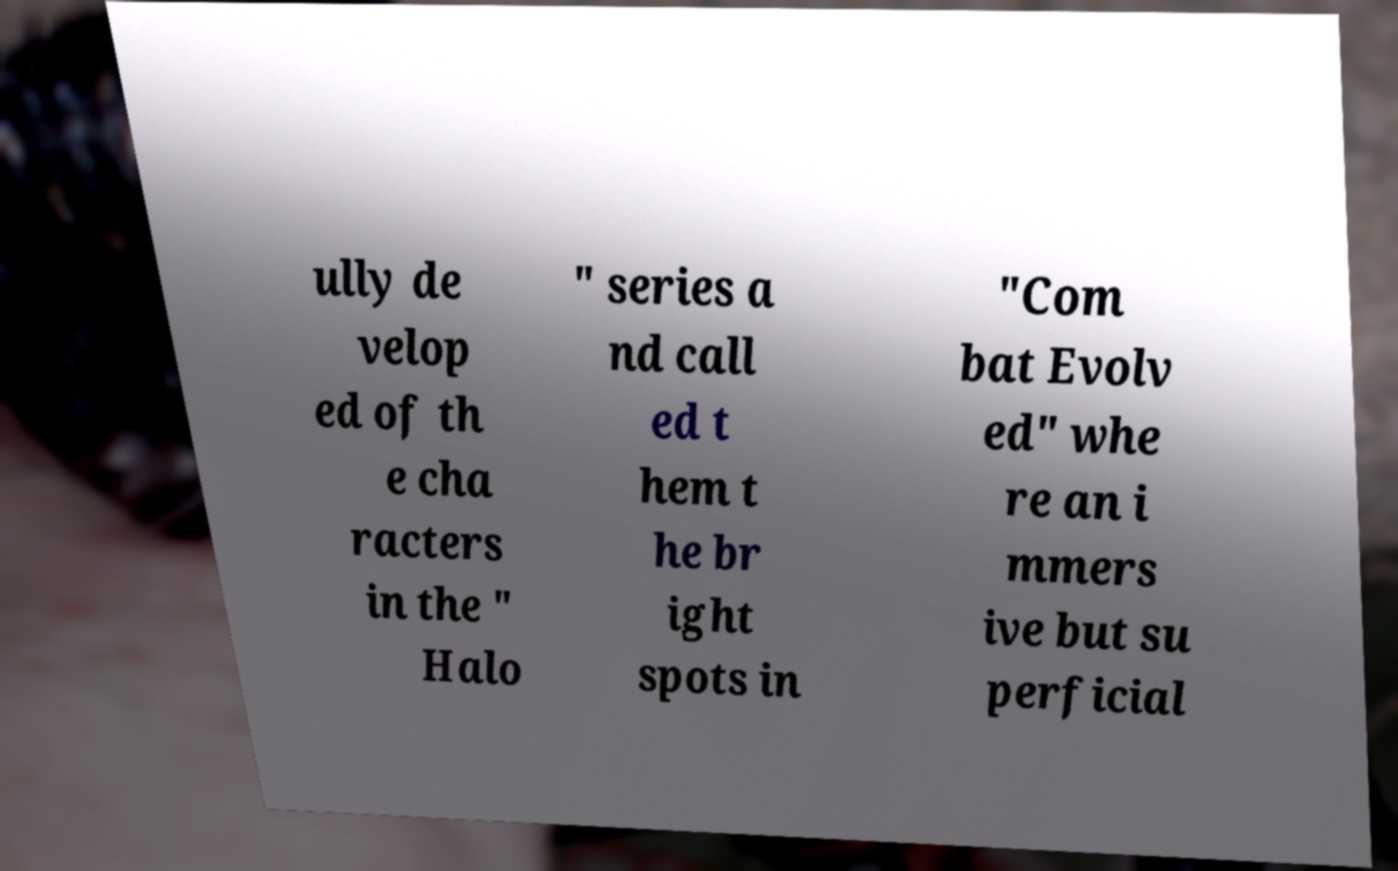Could you assist in decoding the text presented in this image and type it out clearly? ully de velop ed of th e cha racters in the " Halo " series a nd call ed t hem t he br ight spots in "Com bat Evolv ed" whe re an i mmers ive but su perficial 